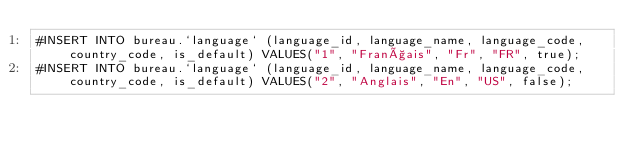<code> <loc_0><loc_0><loc_500><loc_500><_SQL_>#INSERT INTO bureau.`language` (language_id, language_name, language_code, country_code, is_default) VALUES("1", "Français", "Fr", "FR", true);
#INSERT INTO bureau.`language` (language_id, language_name, language_code, country_code, is_default) VALUES("2", "Anglais", "En", "US", false);</code> 